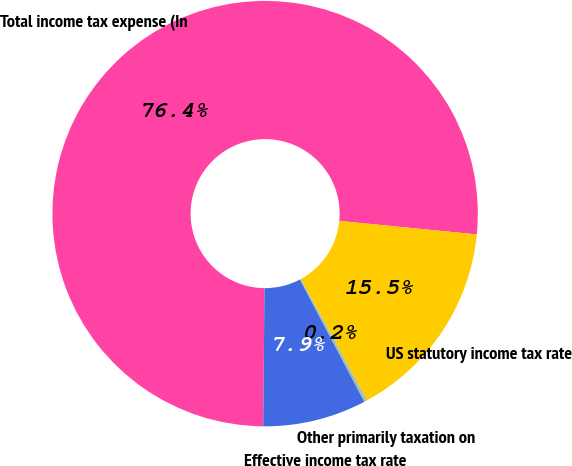Convert chart. <chart><loc_0><loc_0><loc_500><loc_500><pie_chart><fcel>Total income tax expense (In<fcel>US statutory income tax rate<fcel>Other primarily taxation on<fcel>Effective income tax rate<nl><fcel>76.41%<fcel>15.48%<fcel>0.24%<fcel>7.86%<nl></chart> 